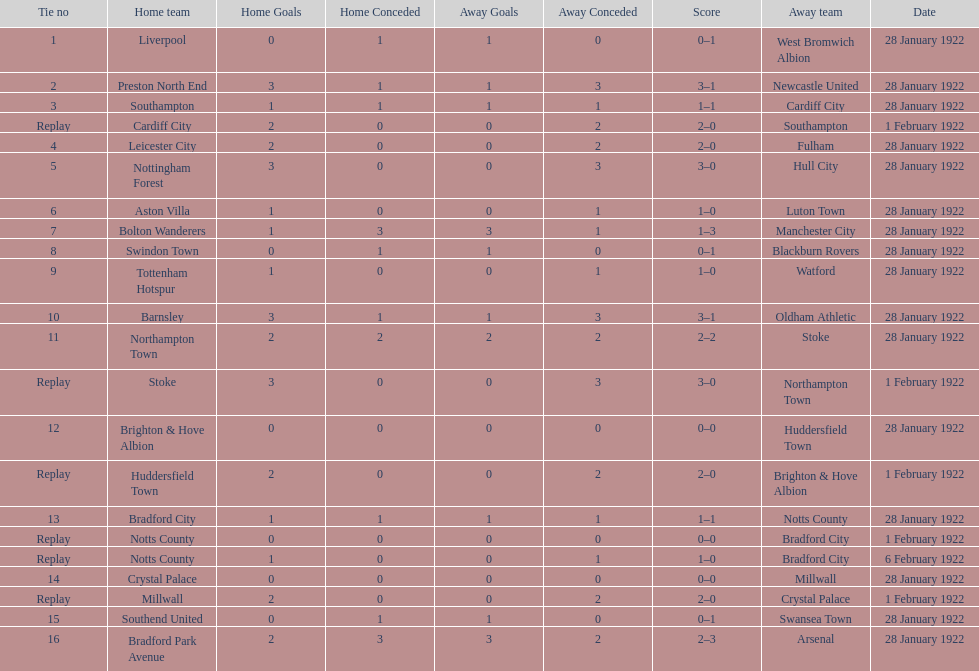How many games had four total points scored or more? 5. 